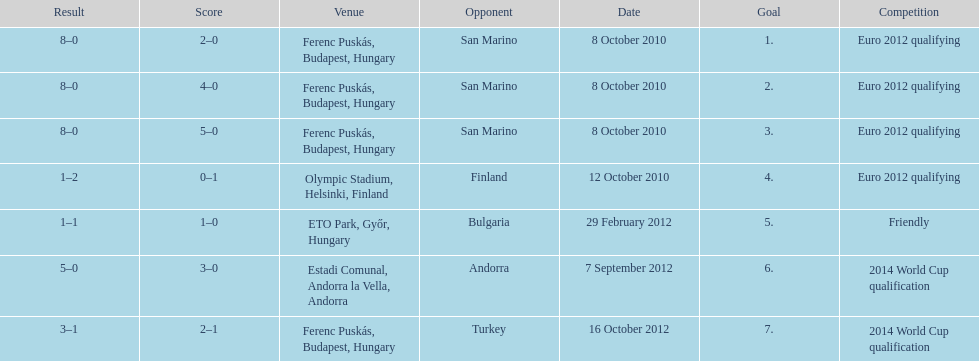What is the total number of international goals ádám szalai has made? 7. 